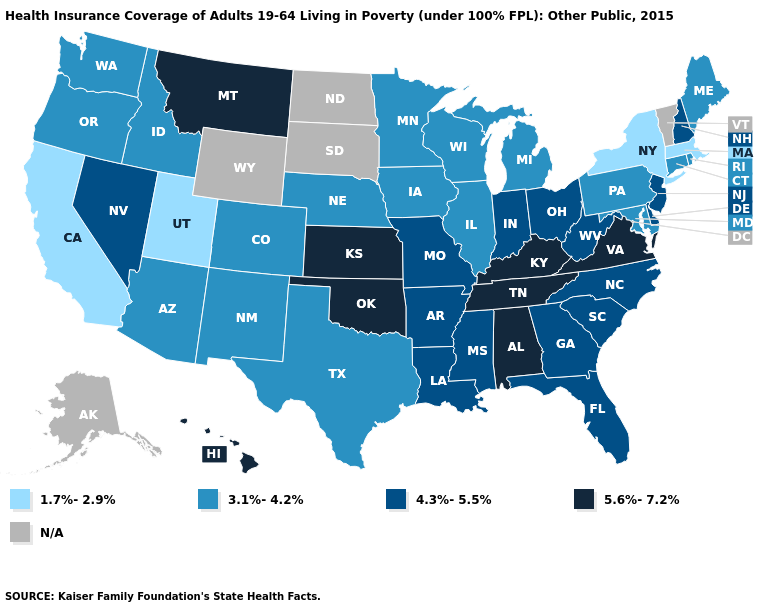Does New York have the lowest value in the USA?
Quick response, please. Yes. What is the lowest value in the West?
Be succinct. 1.7%-2.9%. Is the legend a continuous bar?
Keep it brief. No. Name the states that have a value in the range 3.1%-4.2%?
Give a very brief answer. Arizona, Colorado, Connecticut, Idaho, Illinois, Iowa, Maine, Maryland, Michigan, Minnesota, Nebraska, New Mexico, Oregon, Pennsylvania, Rhode Island, Texas, Washington, Wisconsin. Name the states that have a value in the range 1.7%-2.9%?
Concise answer only. California, Massachusetts, New York, Utah. Name the states that have a value in the range 4.3%-5.5%?
Keep it brief. Arkansas, Delaware, Florida, Georgia, Indiana, Louisiana, Mississippi, Missouri, Nevada, New Hampshire, New Jersey, North Carolina, Ohio, South Carolina, West Virginia. Name the states that have a value in the range 1.7%-2.9%?
Give a very brief answer. California, Massachusetts, New York, Utah. Name the states that have a value in the range 4.3%-5.5%?
Concise answer only. Arkansas, Delaware, Florida, Georgia, Indiana, Louisiana, Mississippi, Missouri, Nevada, New Hampshire, New Jersey, North Carolina, Ohio, South Carolina, West Virginia. Name the states that have a value in the range 3.1%-4.2%?
Answer briefly. Arizona, Colorado, Connecticut, Idaho, Illinois, Iowa, Maine, Maryland, Michigan, Minnesota, Nebraska, New Mexico, Oregon, Pennsylvania, Rhode Island, Texas, Washington, Wisconsin. Name the states that have a value in the range N/A?
Be succinct. Alaska, North Dakota, South Dakota, Vermont, Wyoming. What is the value of Arizona?
Short answer required. 3.1%-4.2%. Name the states that have a value in the range 1.7%-2.9%?
Write a very short answer. California, Massachusetts, New York, Utah. Does Massachusetts have the lowest value in the USA?
Give a very brief answer. Yes. Which states have the highest value in the USA?
Give a very brief answer. Alabama, Hawaii, Kansas, Kentucky, Montana, Oklahoma, Tennessee, Virginia. 